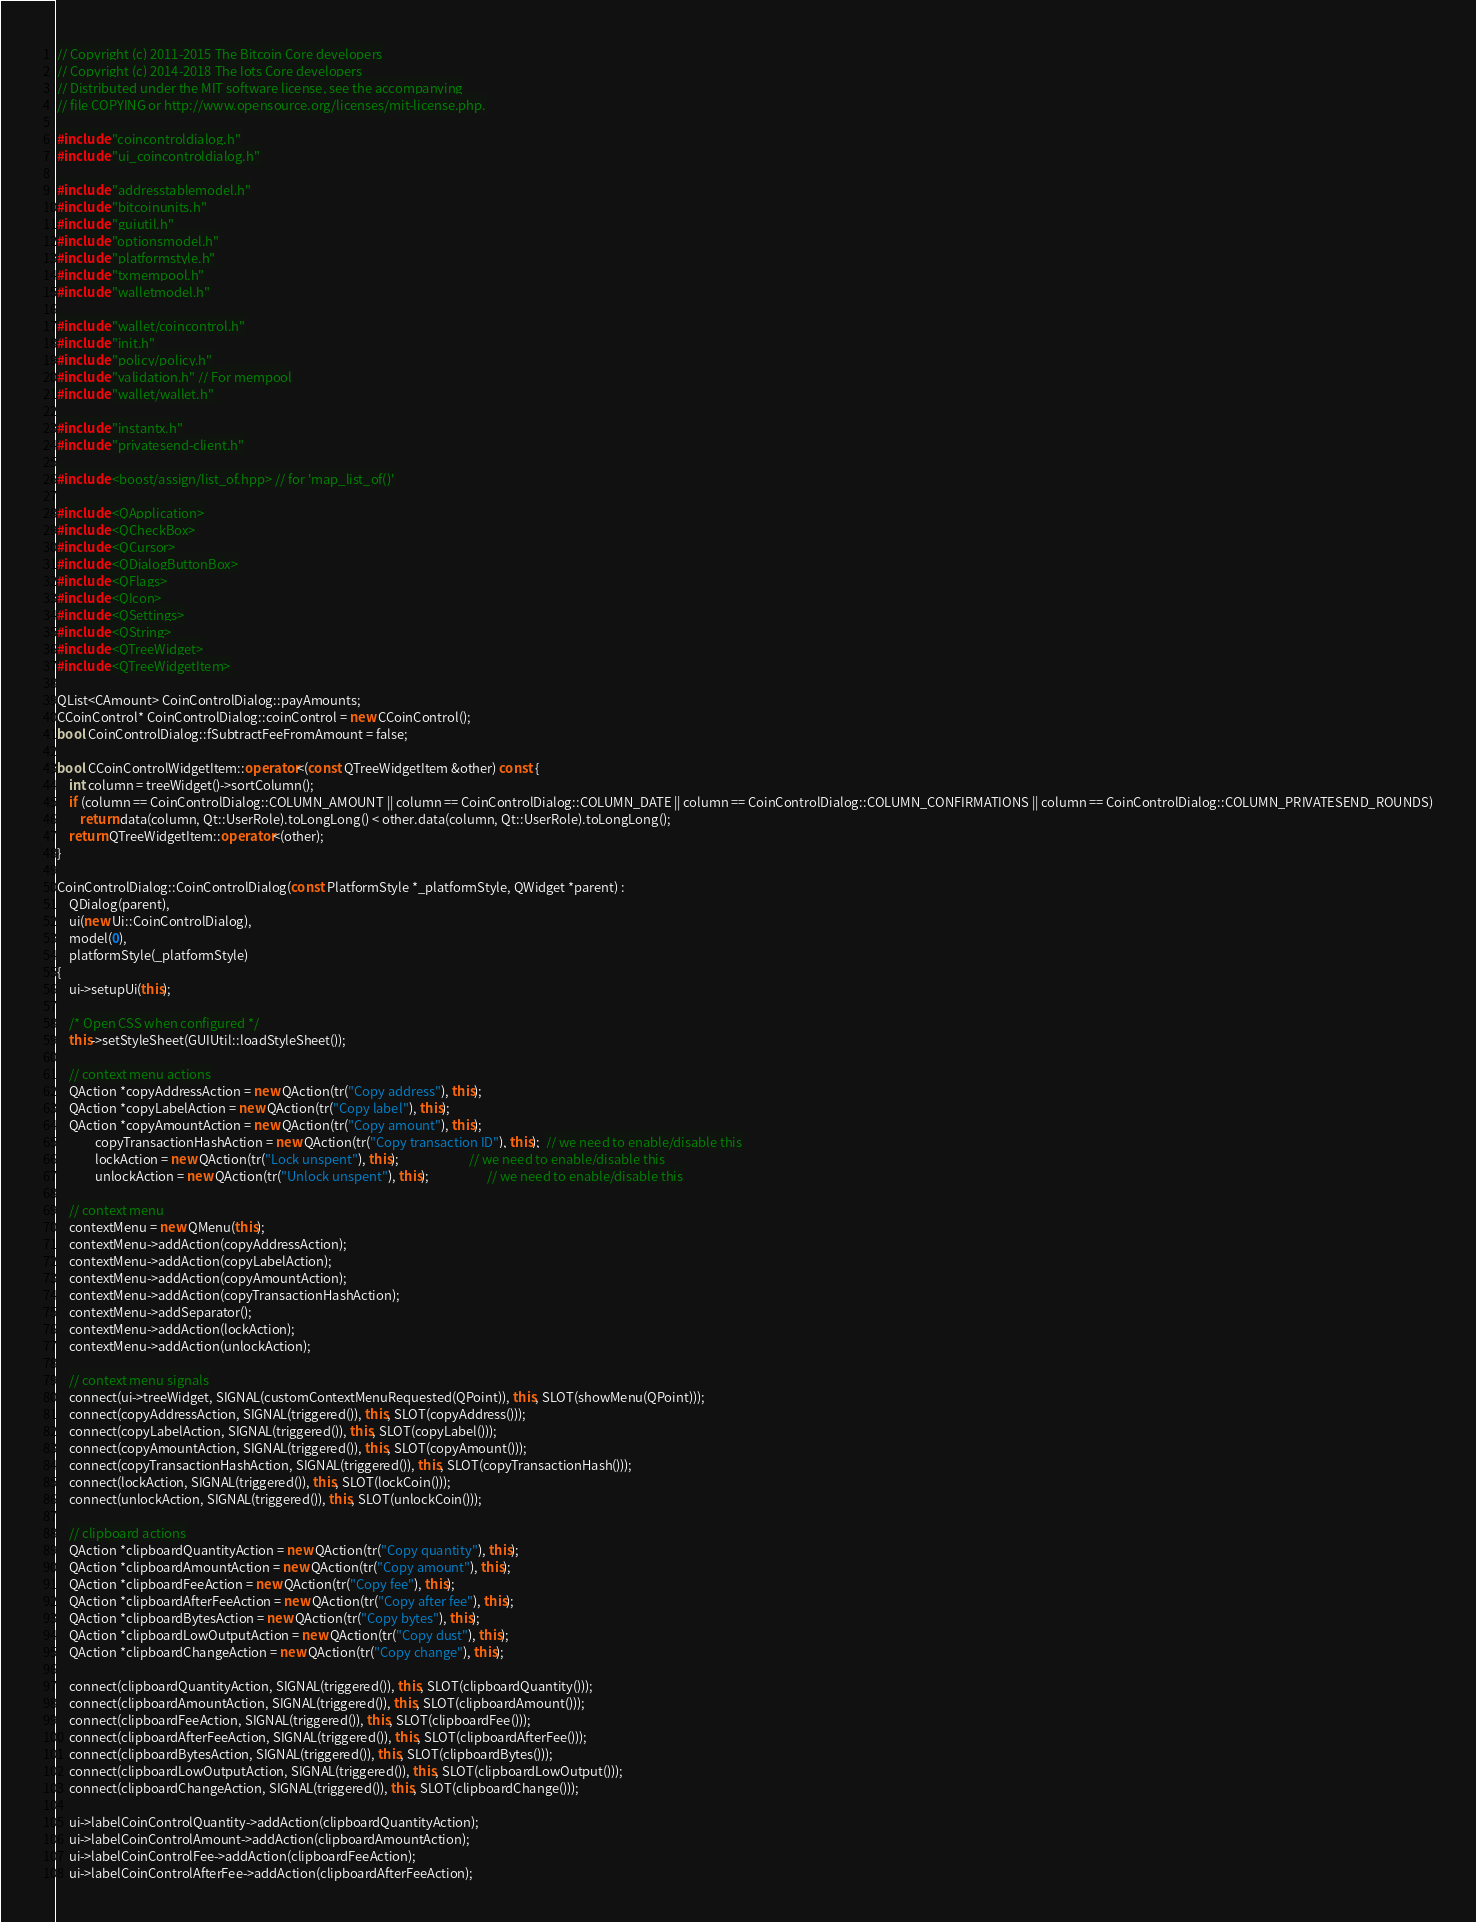<code> <loc_0><loc_0><loc_500><loc_500><_C++_>// Copyright (c) 2011-2015 The Bitcoin Core developers
// Copyright (c) 2014-2018 The Iots Core developers
// Distributed under the MIT software license, see the accompanying
// file COPYING or http://www.opensource.org/licenses/mit-license.php.

#include "coincontroldialog.h"
#include "ui_coincontroldialog.h"

#include "addresstablemodel.h"
#include "bitcoinunits.h"
#include "guiutil.h"
#include "optionsmodel.h"
#include "platformstyle.h"
#include "txmempool.h"
#include "walletmodel.h"

#include "wallet/coincontrol.h"
#include "init.h"
#include "policy/policy.h"
#include "validation.h" // For mempool
#include "wallet/wallet.h"

#include "instantx.h"
#include "privatesend-client.h"

#include <boost/assign/list_of.hpp> // for 'map_list_of()'

#include <QApplication>
#include <QCheckBox>
#include <QCursor>
#include <QDialogButtonBox>
#include <QFlags>
#include <QIcon>
#include <QSettings>
#include <QString>
#include <QTreeWidget>
#include <QTreeWidgetItem>

QList<CAmount> CoinControlDialog::payAmounts;
CCoinControl* CoinControlDialog::coinControl = new CCoinControl();
bool CoinControlDialog::fSubtractFeeFromAmount = false;

bool CCoinControlWidgetItem::operator<(const QTreeWidgetItem &other) const {
    int column = treeWidget()->sortColumn();
    if (column == CoinControlDialog::COLUMN_AMOUNT || column == CoinControlDialog::COLUMN_DATE || column == CoinControlDialog::COLUMN_CONFIRMATIONS || column == CoinControlDialog::COLUMN_PRIVATESEND_ROUNDS)
        return data(column, Qt::UserRole).toLongLong() < other.data(column, Qt::UserRole).toLongLong();
    return QTreeWidgetItem::operator<(other);
}

CoinControlDialog::CoinControlDialog(const PlatformStyle *_platformStyle, QWidget *parent) :
    QDialog(parent),
    ui(new Ui::CoinControlDialog),
    model(0),
    platformStyle(_platformStyle)
{
    ui->setupUi(this);

    /* Open CSS when configured */
    this->setStyleSheet(GUIUtil::loadStyleSheet());

    // context menu actions
    QAction *copyAddressAction = new QAction(tr("Copy address"), this);
    QAction *copyLabelAction = new QAction(tr("Copy label"), this);
    QAction *copyAmountAction = new QAction(tr("Copy amount"), this);
             copyTransactionHashAction = new QAction(tr("Copy transaction ID"), this);  // we need to enable/disable this
             lockAction = new QAction(tr("Lock unspent"), this);                        // we need to enable/disable this
             unlockAction = new QAction(tr("Unlock unspent"), this);                    // we need to enable/disable this

    // context menu
    contextMenu = new QMenu(this);
    contextMenu->addAction(copyAddressAction);
    contextMenu->addAction(copyLabelAction);
    contextMenu->addAction(copyAmountAction);
    contextMenu->addAction(copyTransactionHashAction);
    contextMenu->addSeparator();
    contextMenu->addAction(lockAction);
    contextMenu->addAction(unlockAction);

    // context menu signals
    connect(ui->treeWidget, SIGNAL(customContextMenuRequested(QPoint)), this, SLOT(showMenu(QPoint)));
    connect(copyAddressAction, SIGNAL(triggered()), this, SLOT(copyAddress()));
    connect(copyLabelAction, SIGNAL(triggered()), this, SLOT(copyLabel()));
    connect(copyAmountAction, SIGNAL(triggered()), this, SLOT(copyAmount()));
    connect(copyTransactionHashAction, SIGNAL(triggered()), this, SLOT(copyTransactionHash()));
    connect(lockAction, SIGNAL(triggered()), this, SLOT(lockCoin()));
    connect(unlockAction, SIGNAL(triggered()), this, SLOT(unlockCoin()));

    // clipboard actions
    QAction *clipboardQuantityAction = new QAction(tr("Copy quantity"), this);
    QAction *clipboardAmountAction = new QAction(tr("Copy amount"), this);
    QAction *clipboardFeeAction = new QAction(tr("Copy fee"), this);
    QAction *clipboardAfterFeeAction = new QAction(tr("Copy after fee"), this);
    QAction *clipboardBytesAction = new QAction(tr("Copy bytes"), this);
    QAction *clipboardLowOutputAction = new QAction(tr("Copy dust"), this);
    QAction *clipboardChangeAction = new QAction(tr("Copy change"), this);

    connect(clipboardQuantityAction, SIGNAL(triggered()), this, SLOT(clipboardQuantity()));
    connect(clipboardAmountAction, SIGNAL(triggered()), this, SLOT(clipboardAmount()));
    connect(clipboardFeeAction, SIGNAL(triggered()), this, SLOT(clipboardFee()));
    connect(clipboardAfterFeeAction, SIGNAL(triggered()), this, SLOT(clipboardAfterFee()));
    connect(clipboardBytesAction, SIGNAL(triggered()), this, SLOT(clipboardBytes()));
    connect(clipboardLowOutputAction, SIGNAL(triggered()), this, SLOT(clipboardLowOutput()));
    connect(clipboardChangeAction, SIGNAL(triggered()), this, SLOT(clipboardChange()));

    ui->labelCoinControlQuantity->addAction(clipboardQuantityAction);
    ui->labelCoinControlAmount->addAction(clipboardAmountAction);
    ui->labelCoinControlFee->addAction(clipboardFeeAction);
    ui->labelCoinControlAfterFee->addAction(clipboardAfterFeeAction);</code> 